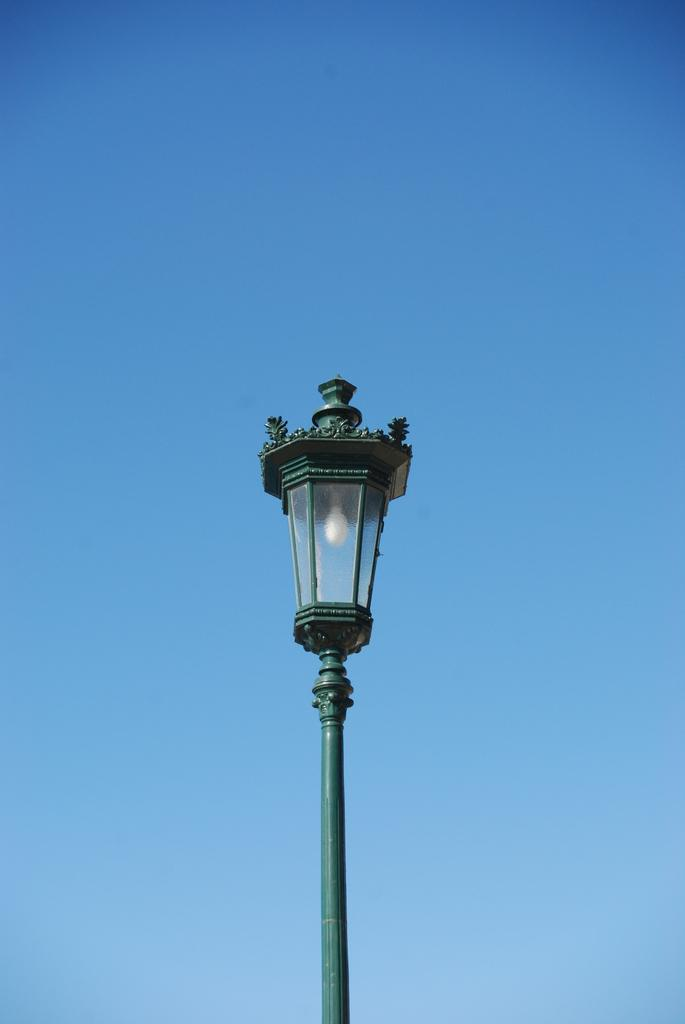What type of light source is present in the image? There is a pole light in the image. What color is the sky in the image? The sky is blue in the image. What is the temperature of the fact in the image? There is no fact or temperature mentioned in the image; it only contains a pole light and a blue sky. 